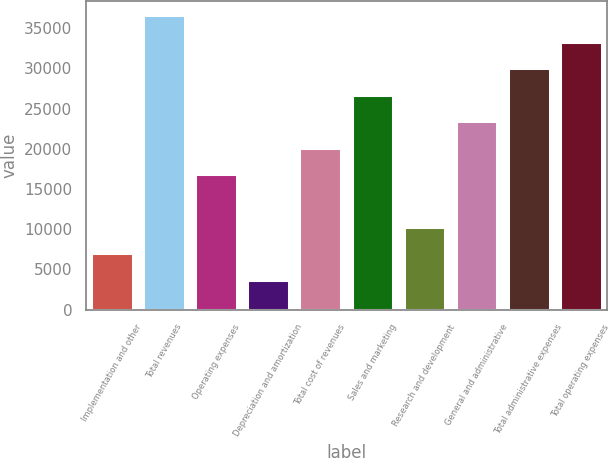<chart> <loc_0><loc_0><loc_500><loc_500><bar_chart><fcel>Implementation and other<fcel>Total revenues<fcel>Operating expenses<fcel>Depreciation and amortization<fcel>Total cost of revenues<fcel>Sales and marketing<fcel>Research and development<fcel>General and administrative<fcel>Total administrative expenses<fcel>Total operating expenses<nl><fcel>7016.4<fcel>36592.2<fcel>16875<fcel>3730.2<fcel>20161.2<fcel>26733.6<fcel>10302.6<fcel>23447.4<fcel>30019.8<fcel>33306<nl></chart> 